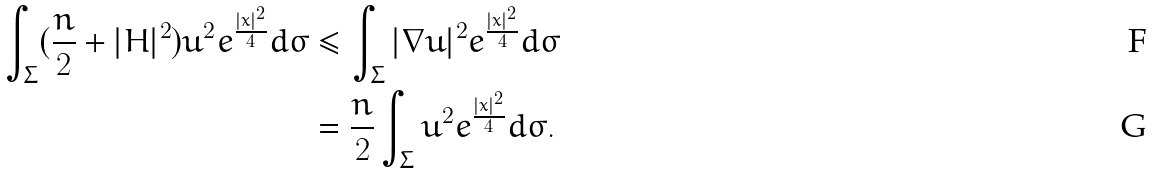Convert formula to latex. <formula><loc_0><loc_0><loc_500><loc_500>\int _ { \Sigma } ( \frac { n } { 2 } + | { H } | ^ { 2 } ) u ^ { 2 } e ^ { \frac { | x | ^ { 2 } } { 4 } } d \sigma & \leq \int _ { \Sigma } | \nabla u | ^ { 2 } e ^ { \frac { | x | ^ { 2 } } { 4 } } d \sigma \\ & = \frac { n } { 2 } \int _ { \Sigma } u ^ { 2 } e ^ { \frac { | x | ^ { 2 } } { 4 } } d \sigma .</formula> 